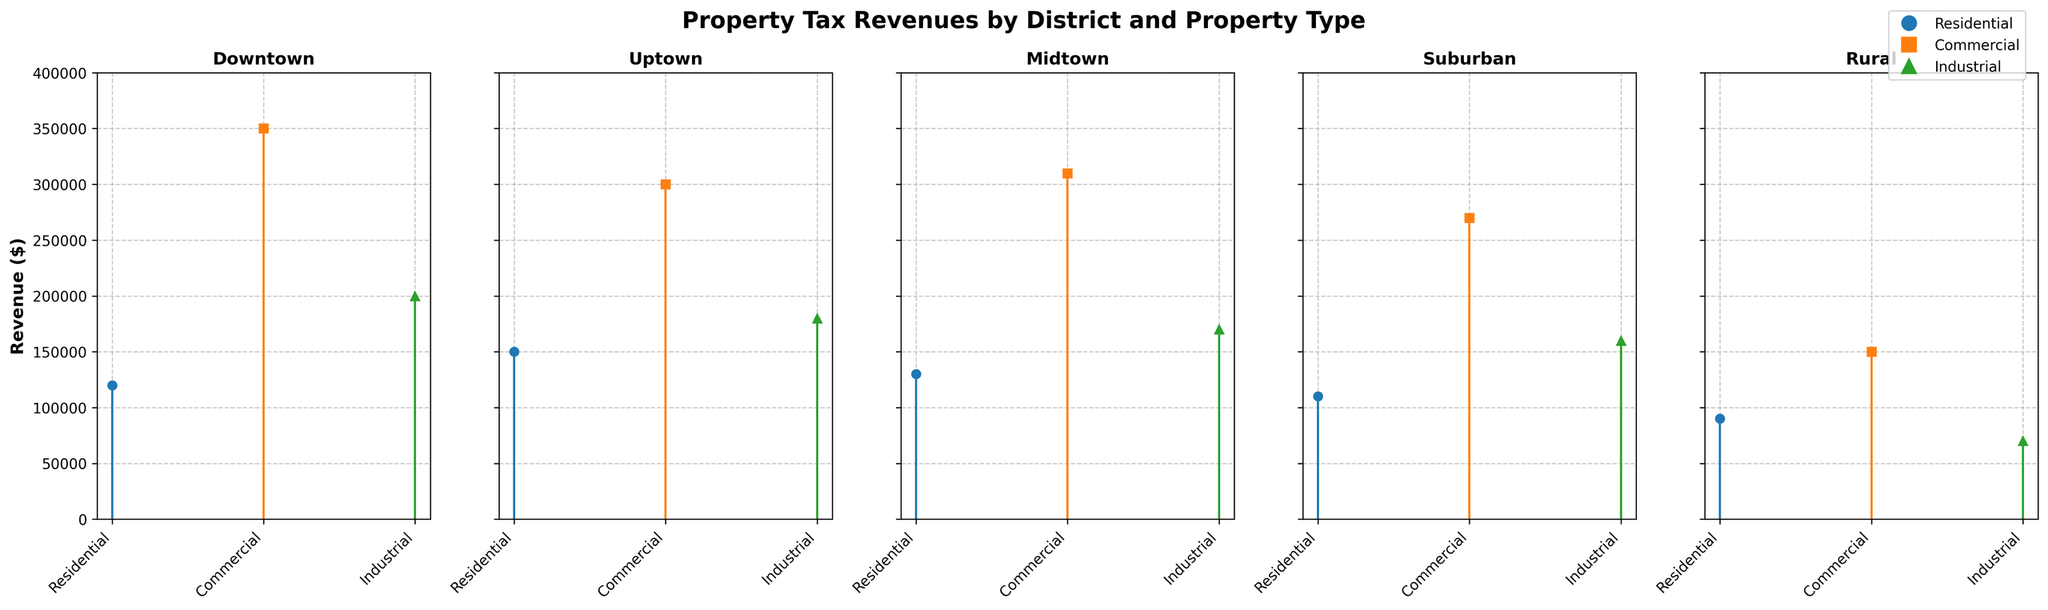what is the total revenue generated from Residential properties in Downtown? Identify the revenue from Residential properties in the Downtown district stem plot, which is $120,000, and provide it as the answer.
Answer: $120,000 Which district has the highest revenue from Commercial properties? Compare the revenue from Commercial properties across all districts (Downtown: $350,000, Uptown: $300,000, Midtown: $310,000, Suburban: $270,000, Rural: $150,000). Downtown has the highest revenue.
Answer: Downtown What is the difference in revenue between Industrial and Residential properties in Uptown? Identify the revenue from Industrial ($180,000) and Residential ($150,000) properties in Uptown, then find the difference by subtracting the Residential revenue from the Industrial revenue: $180,000 - $150,000 = $30,000.
Answer: $30,000 Which property type generates the highest revenue in Midtown? Compare the revenues of different property types in Midtown (Residential: $130,000, Commercial: $310,000, Industrial: $170,000). Commercial properties generate the highest revenue.
Answer: Commercial Rank the districts based on their total revenue from all property types combined. Sum the revenues from all property types for each district (Downtown: $120,000 + $350,000 + $200,000 = $670,000, Uptown: $150,000 + $300,000 + $180,000 = $630,000, Midtown: $130,000 + $310,000 + $170,000 = $610,000, Suburban: $110,000 + $270,000 + $160,000 = $540,000, Rural: $90,000 + $150,000 + $70,000 = $310,000). Rank the totals (Downtown: $670,000, Uptown: $630,000, Midtown: $610,000, Suburban: $540,000, Rural: $310,000).
Answer: Downtown, Uptown, Midtown, Suburban, Rural Identify the property type with the lowest revenue in Suburban district. Compare the revenues of different property types in Suburban (Residential: $110,000, Commercial: $270,000, Industrial: $160,000). Residential has the lowest revenue.
Answer: Residential Is the revenue from Residential properties in Rural higher or lower than in Suburban? Compare the revenue from Residential properties in Rural ($90,000) and Suburban ($110,000). The revenue in Rural is lower.
Answer: Lower 